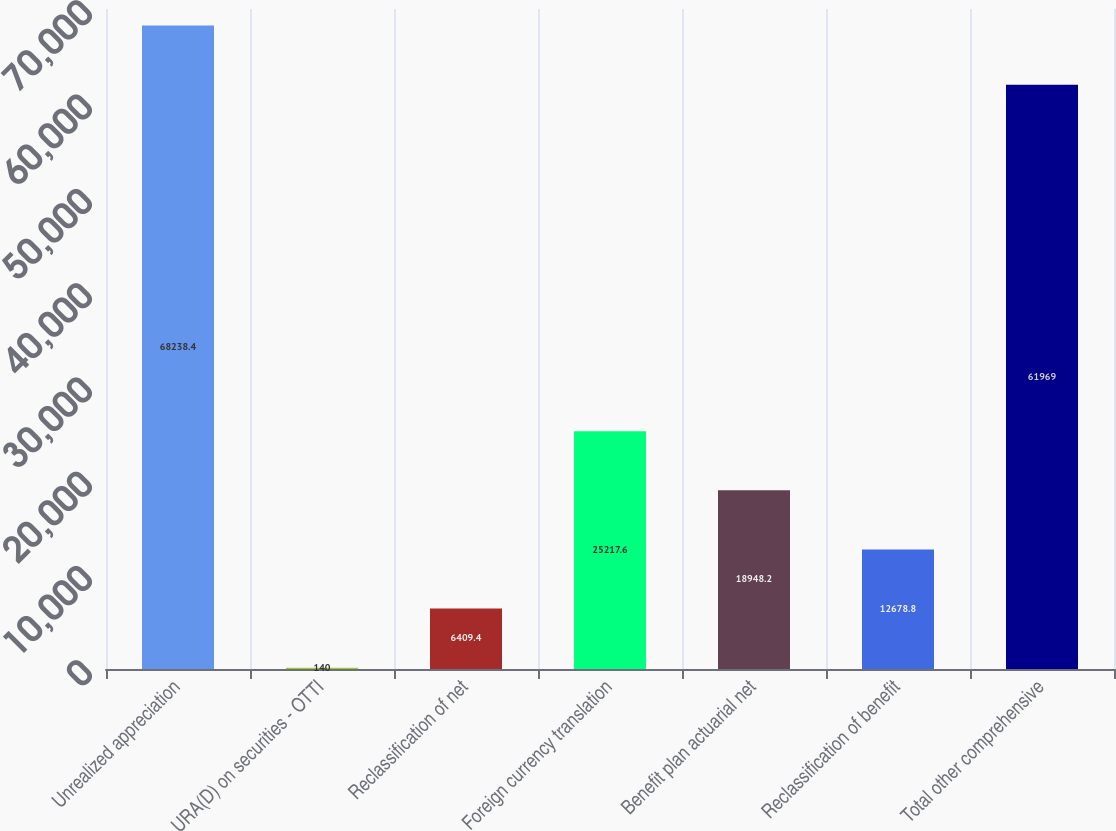Convert chart. <chart><loc_0><loc_0><loc_500><loc_500><bar_chart><fcel>Unrealized appreciation<fcel>URA(D) on securities - OTTI<fcel>Reclassification of net<fcel>Foreign currency translation<fcel>Benefit plan actuarial net<fcel>Reclassification of benefit<fcel>Total other comprehensive<nl><fcel>68238.4<fcel>140<fcel>6409.4<fcel>25217.6<fcel>18948.2<fcel>12678.8<fcel>61969<nl></chart> 